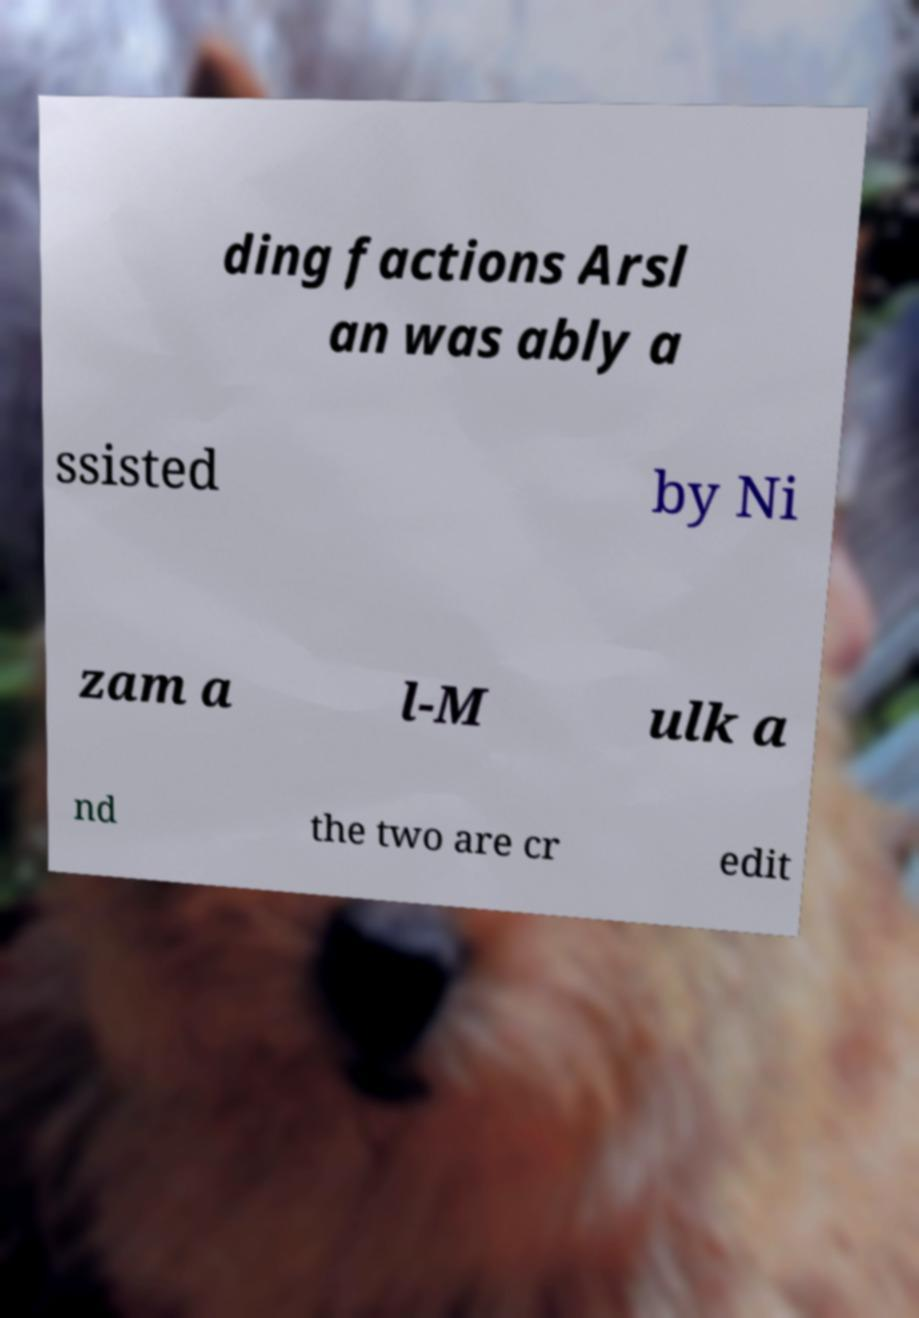I need the written content from this picture converted into text. Can you do that? ding factions Arsl an was ably a ssisted by Ni zam a l-M ulk a nd the two are cr edit 